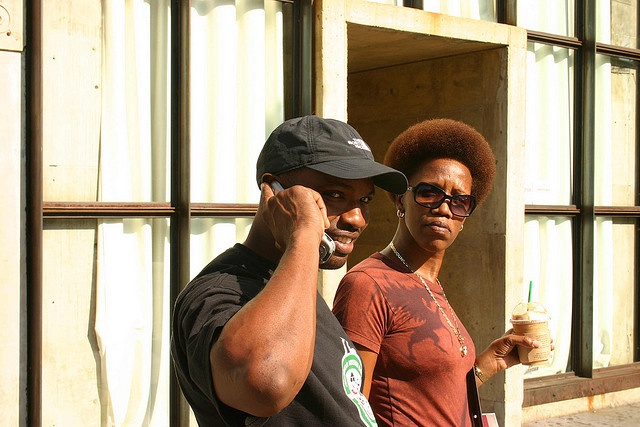Describe the objects in this image and their specific colors. I can see people in tan, black, maroon, gray, and salmon tones, people in tan, maroon, black, brown, and salmon tones, cup in tan, khaki, brown, and beige tones, handbag in tan, black, ivory, and salmon tones, and cell phone in tan, black, maroon, gray, and ivory tones in this image. 